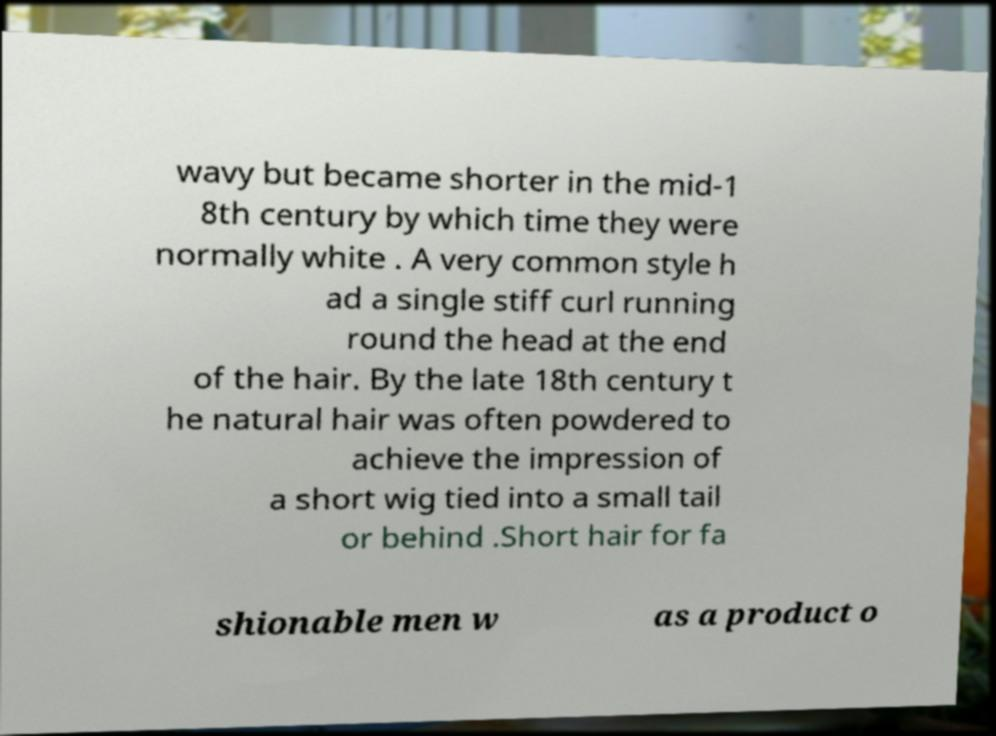I need the written content from this picture converted into text. Can you do that? wavy but became shorter in the mid-1 8th century by which time they were normally white . A very common style h ad a single stiff curl running round the head at the end of the hair. By the late 18th century t he natural hair was often powdered to achieve the impression of a short wig tied into a small tail or behind .Short hair for fa shionable men w as a product o 